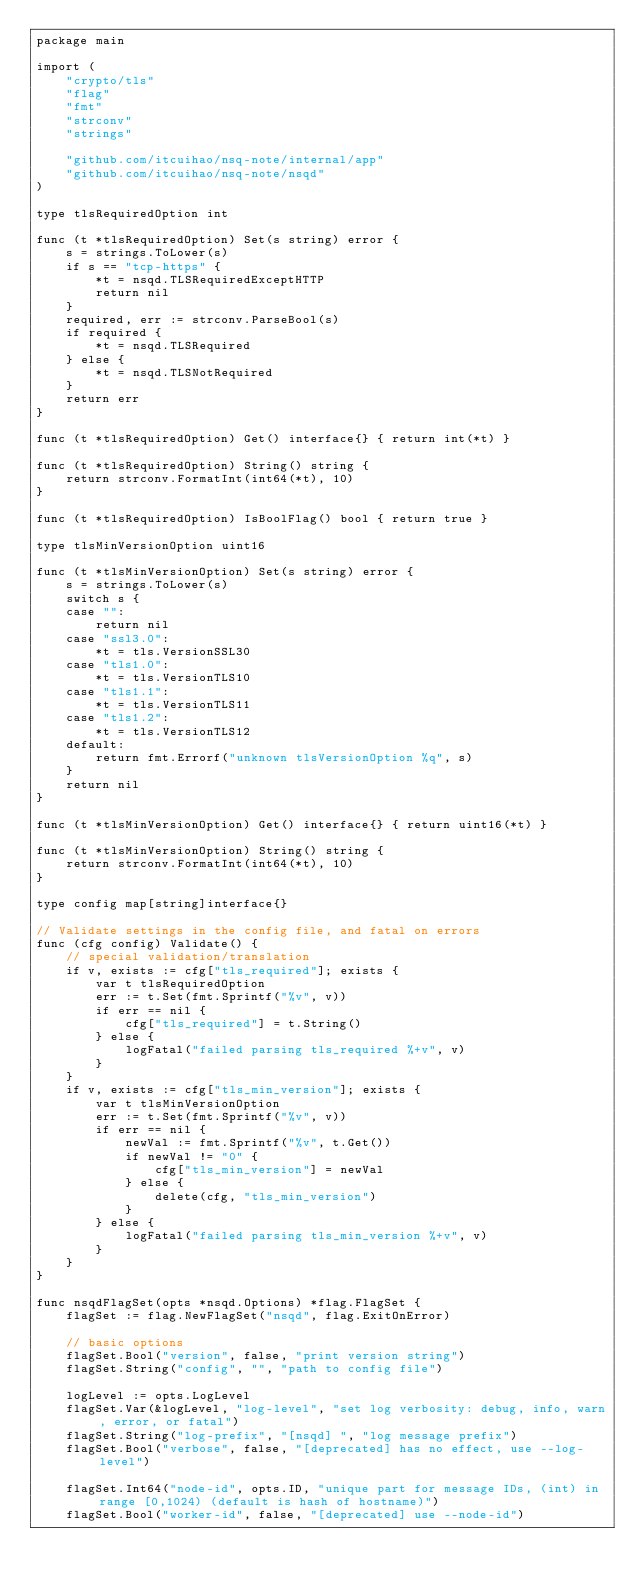<code> <loc_0><loc_0><loc_500><loc_500><_Go_>package main

import (
	"crypto/tls"
	"flag"
	"fmt"
	"strconv"
	"strings"

	"github.com/itcuihao/nsq-note/internal/app"
	"github.com/itcuihao/nsq-note/nsqd"
)

type tlsRequiredOption int

func (t *tlsRequiredOption) Set(s string) error {
	s = strings.ToLower(s)
	if s == "tcp-https" {
		*t = nsqd.TLSRequiredExceptHTTP
		return nil
	}
	required, err := strconv.ParseBool(s)
	if required {
		*t = nsqd.TLSRequired
	} else {
		*t = nsqd.TLSNotRequired
	}
	return err
}

func (t *tlsRequiredOption) Get() interface{} { return int(*t) }

func (t *tlsRequiredOption) String() string {
	return strconv.FormatInt(int64(*t), 10)
}

func (t *tlsRequiredOption) IsBoolFlag() bool { return true }

type tlsMinVersionOption uint16

func (t *tlsMinVersionOption) Set(s string) error {
	s = strings.ToLower(s)
	switch s {
	case "":
		return nil
	case "ssl3.0":
		*t = tls.VersionSSL30
	case "tls1.0":
		*t = tls.VersionTLS10
	case "tls1.1":
		*t = tls.VersionTLS11
	case "tls1.2":
		*t = tls.VersionTLS12
	default:
		return fmt.Errorf("unknown tlsVersionOption %q", s)
	}
	return nil
}

func (t *tlsMinVersionOption) Get() interface{} { return uint16(*t) }

func (t *tlsMinVersionOption) String() string {
	return strconv.FormatInt(int64(*t), 10)
}

type config map[string]interface{}

// Validate settings in the config file, and fatal on errors
func (cfg config) Validate() {
	// special validation/translation
	if v, exists := cfg["tls_required"]; exists {
		var t tlsRequiredOption
		err := t.Set(fmt.Sprintf("%v", v))
		if err == nil {
			cfg["tls_required"] = t.String()
		} else {
			logFatal("failed parsing tls_required %+v", v)
		}
	}
	if v, exists := cfg["tls_min_version"]; exists {
		var t tlsMinVersionOption
		err := t.Set(fmt.Sprintf("%v", v))
		if err == nil {
			newVal := fmt.Sprintf("%v", t.Get())
			if newVal != "0" {
				cfg["tls_min_version"] = newVal
			} else {
				delete(cfg, "tls_min_version")
			}
		} else {
			logFatal("failed parsing tls_min_version %+v", v)
		}
	}
}

func nsqdFlagSet(opts *nsqd.Options) *flag.FlagSet {
	flagSet := flag.NewFlagSet("nsqd", flag.ExitOnError)

	// basic options
	flagSet.Bool("version", false, "print version string")
	flagSet.String("config", "", "path to config file")

	logLevel := opts.LogLevel
	flagSet.Var(&logLevel, "log-level", "set log verbosity: debug, info, warn, error, or fatal")
	flagSet.String("log-prefix", "[nsqd] ", "log message prefix")
	flagSet.Bool("verbose", false, "[deprecated] has no effect, use --log-level")

	flagSet.Int64("node-id", opts.ID, "unique part for message IDs, (int) in range [0,1024) (default is hash of hostname)")
	flagSet.Bool("worker-id", false, "[deprecated] use --node-id")
</code> 